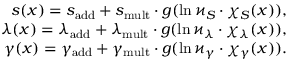Convert formula to latex. <formula><loc_0><loc_0><loc_500><loc_500>\begin{array} { r } { s ( x ) = { s } _ { a d d } + { s } _ { m u l t } \cdot g ( \ln \varkappa _ { S } \cdot \chi _ { S } ( x ) ) , } \\ { \lambda ( x ) = \lambda _ { a d d } + { \lambda } _ { m u l t } \cdot g ( \ln \varkappa _ { \lambda } \cdot \chi _ { \lambda } ( x ) ) , } \\ { \gamma ( x ) = \gamma _ { a d d } + \gamma _ { m u l t } \cdot g ( \ln \varkappa _ { \gamma } \cdot \chi _ { \gamma } ( x ) ) . } \end{array}</formula> 